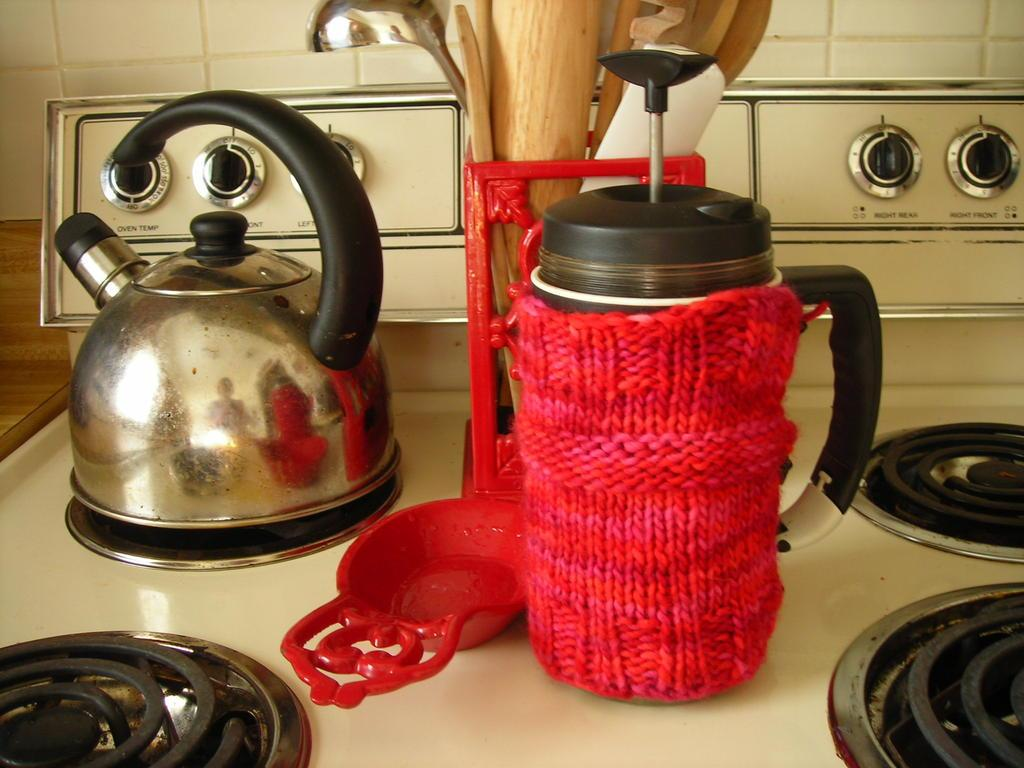<image>
Relay a brief, clear account of the picture shown. a stove top with oven dials with the words 'oven temp' underneath it 